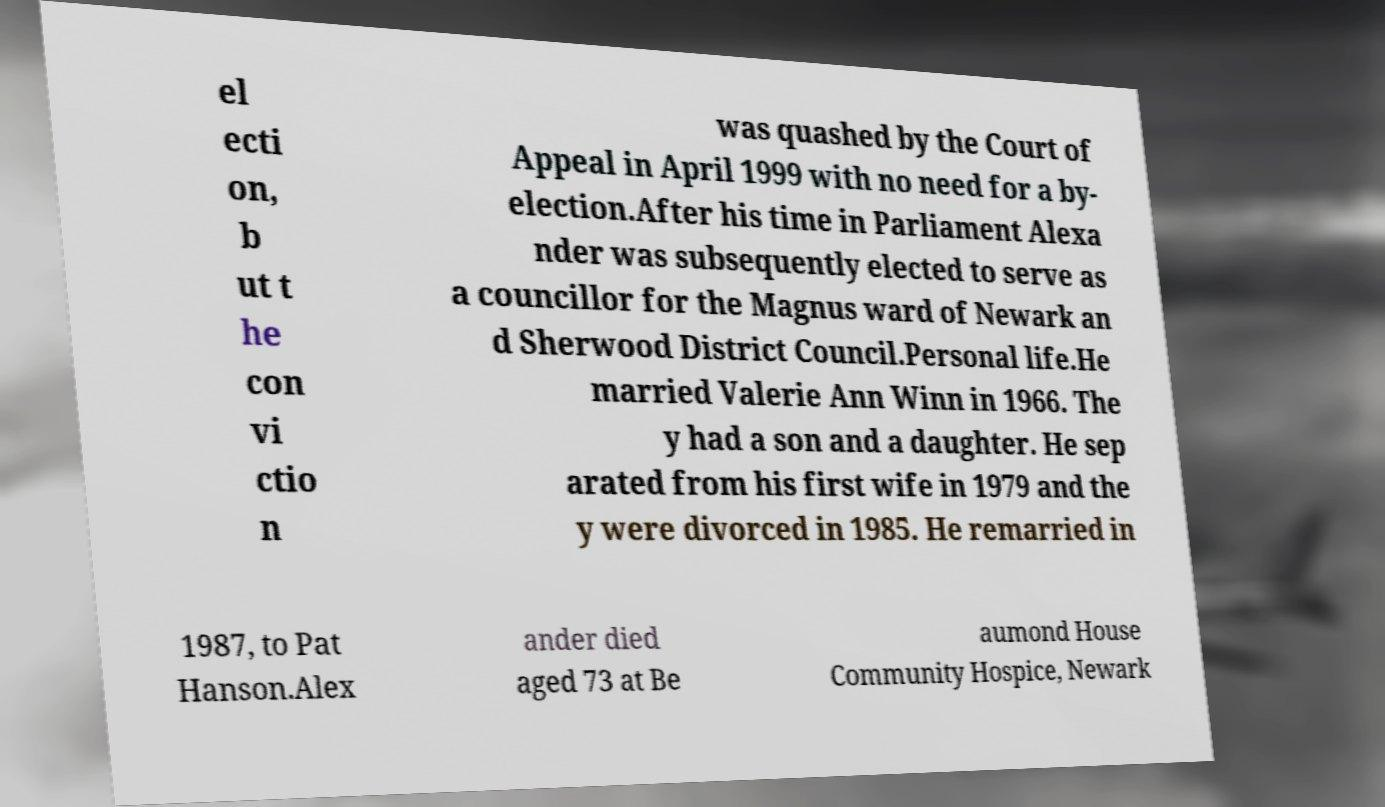There's text embedded in this image that I need extracted. Can you transcribe it verbatim? el ecti on, b ut t he con vi ctio n was quashed by the Court of Appeal in April 1999 with no need for a by- election.After his time in Parliament Alexa nder was subsequently elected to serve as a councillor for the Magnus ward of Newark an d Sherwood District Council.Personal life.He married Valerie Ann Winn in 1966. The y had a son and a daughter. He sep arated from his first wife in 1979 and the y were divorced in 1985. He remarried in 1987, to Pat Hanson.Alex ander died aged 73 at Be aumond House Community Hospice, Newark 